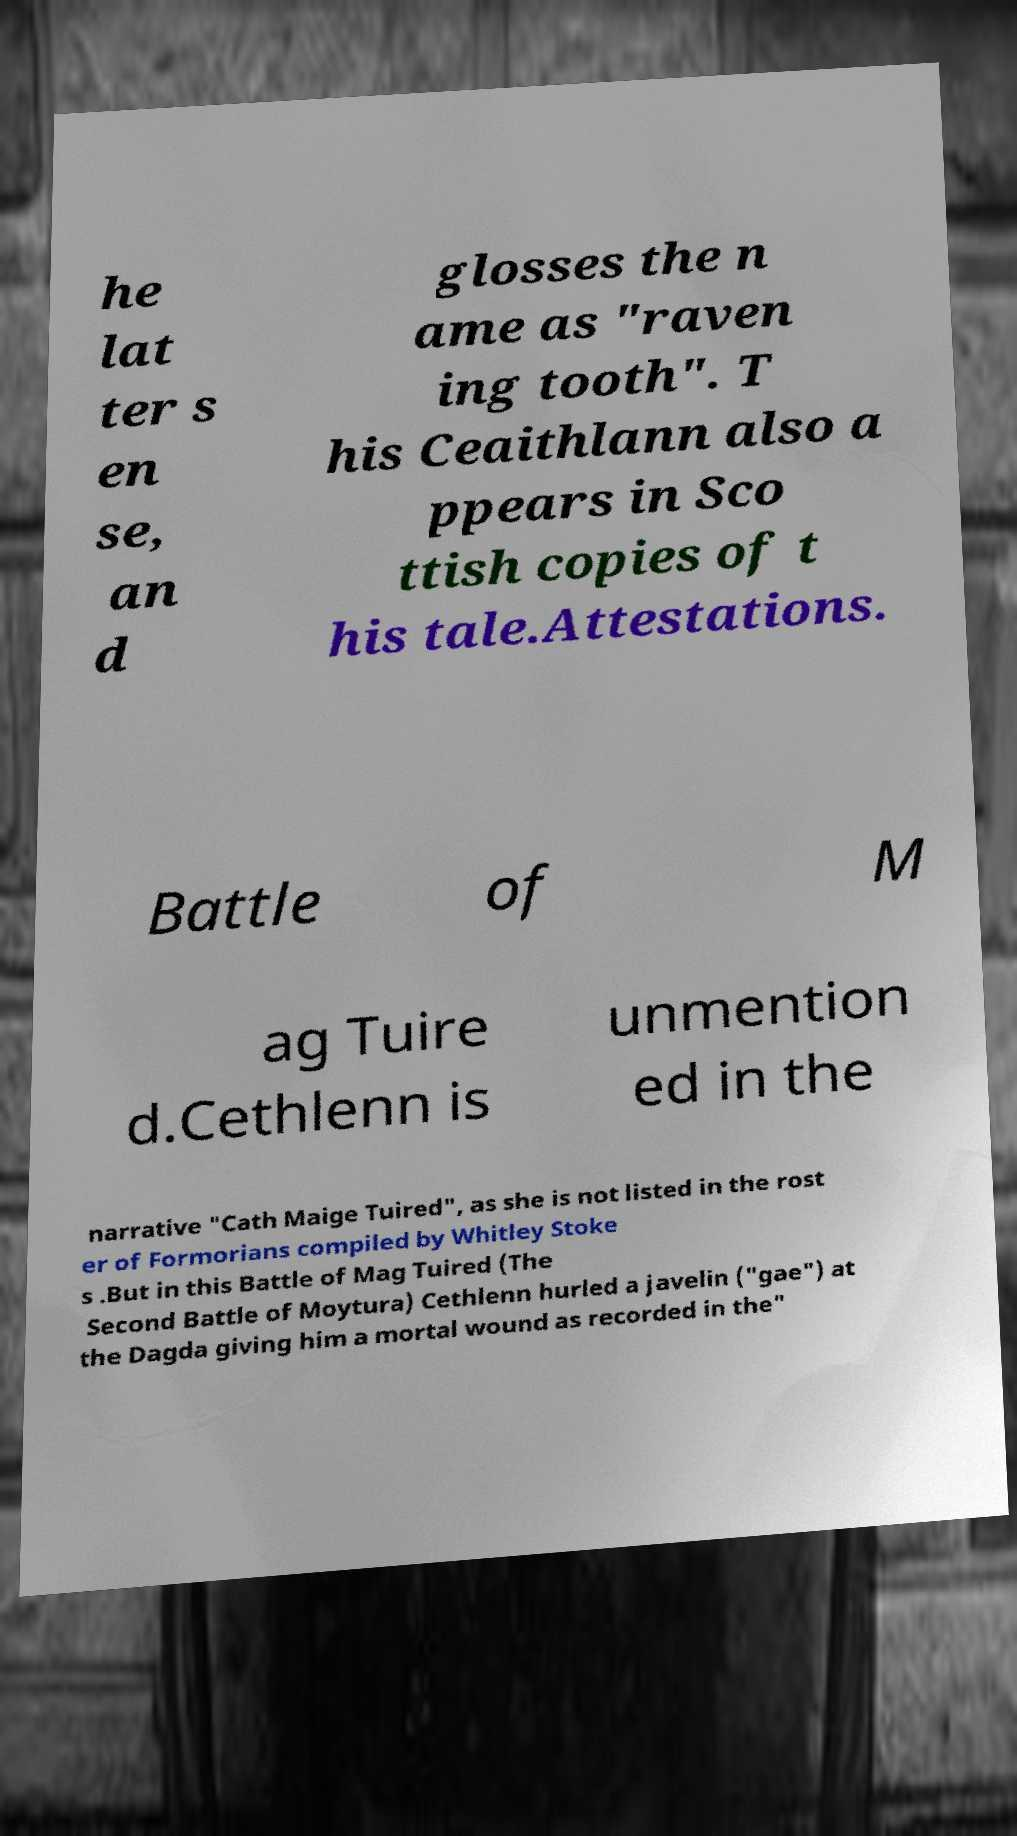Please read and relay the text visible in this image. What does it say? he lat ter s en se, an d glosses the n ame as "raven ing tooth". T his Ceaithlann also a ppears in Sco ttish copies of t his tale.Attestations. Battle of M ag Tuire d.Cethlenn is unmention ed in the narrative "Cath Maige Tuired", as she is not listed in the rost er of Formorians compiled by Whitley Stoke s .But in this Battle of Mag Tuired (The Second Battle of Moytura) Cethlenn hurled a javelin ("gae") at the Dagda giving him a mortal wound as recorded in the" 